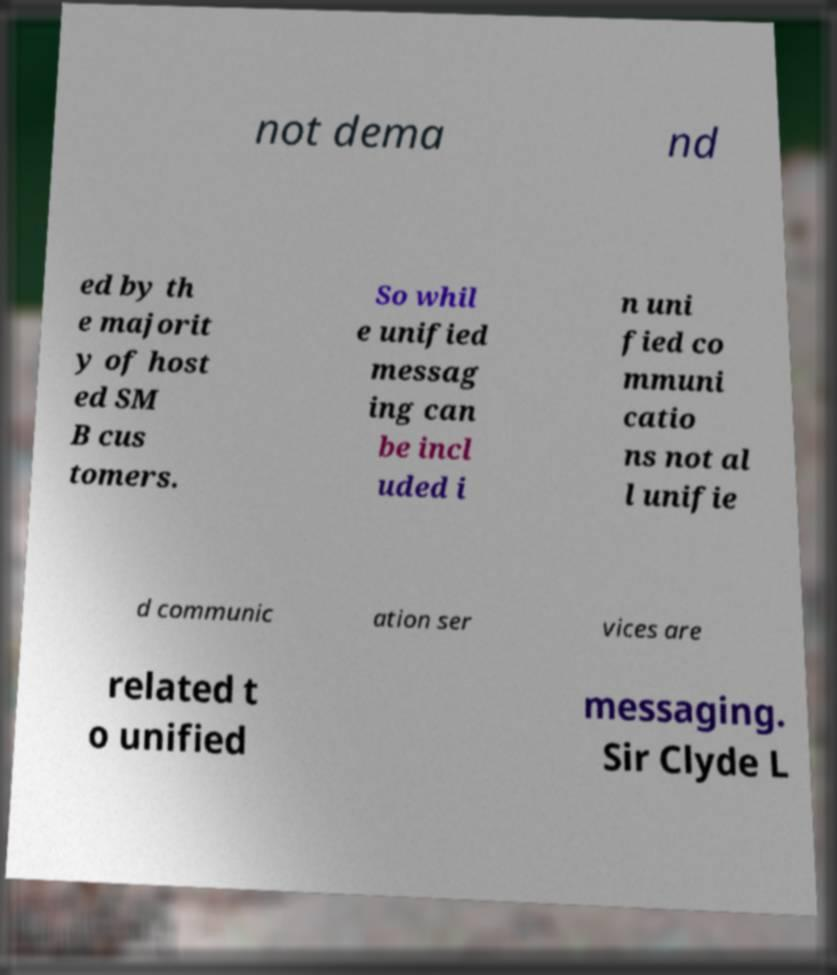Can you read and provide the text displayed in the image?This photo seems to have some interesting text. Can you extract and type it out for me? not dema nd ed by th e majorit y of host ed SM B cus tomers. So whil e unified messag ing can be incl uded i n uni fied co mmuni catio ns not al l unifie d communic ation ser vices are related t o unified messaging. Sir Clyde L 